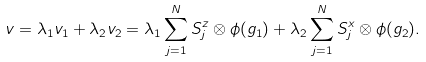<formula> <loc_0><loc_0><loc_500><loc_500>v = \lambda _ { 1 } v _ { 1 } + \lambda _ { 2 } v _ { 2 } = \lambda _ { 1 } \sum _ { j = 1 } ^ { N } S _ { j } ^ { z } \otimes \phi ( g _ { 1 } ) + \lambda _ { 2 } \sum _ { j = 1 } ^ { N } S _ { j } ^ { x } \otimes \phi ( g _ { 2 } ) .</formula> 